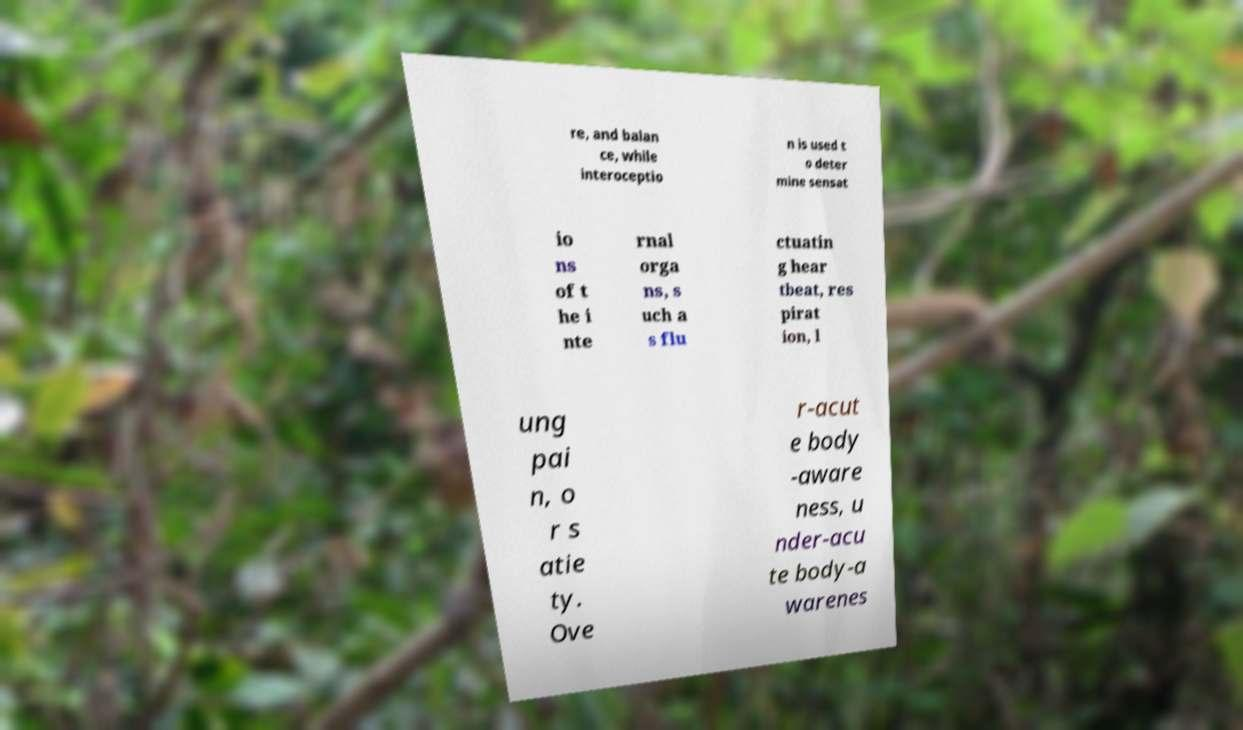Can you accurately transcribe the text from the provided image for me? re, and balan ce, while interoceptio n is used t o deter mine sensat io ns of t he i nte rnal orga ns, s uch a s flu ctuatin g hear tbeat, res pirat ion, l ung pai n, o r s atie ty. Ove r-acut e body -aware ness, u nder-acu te body-a warenes 